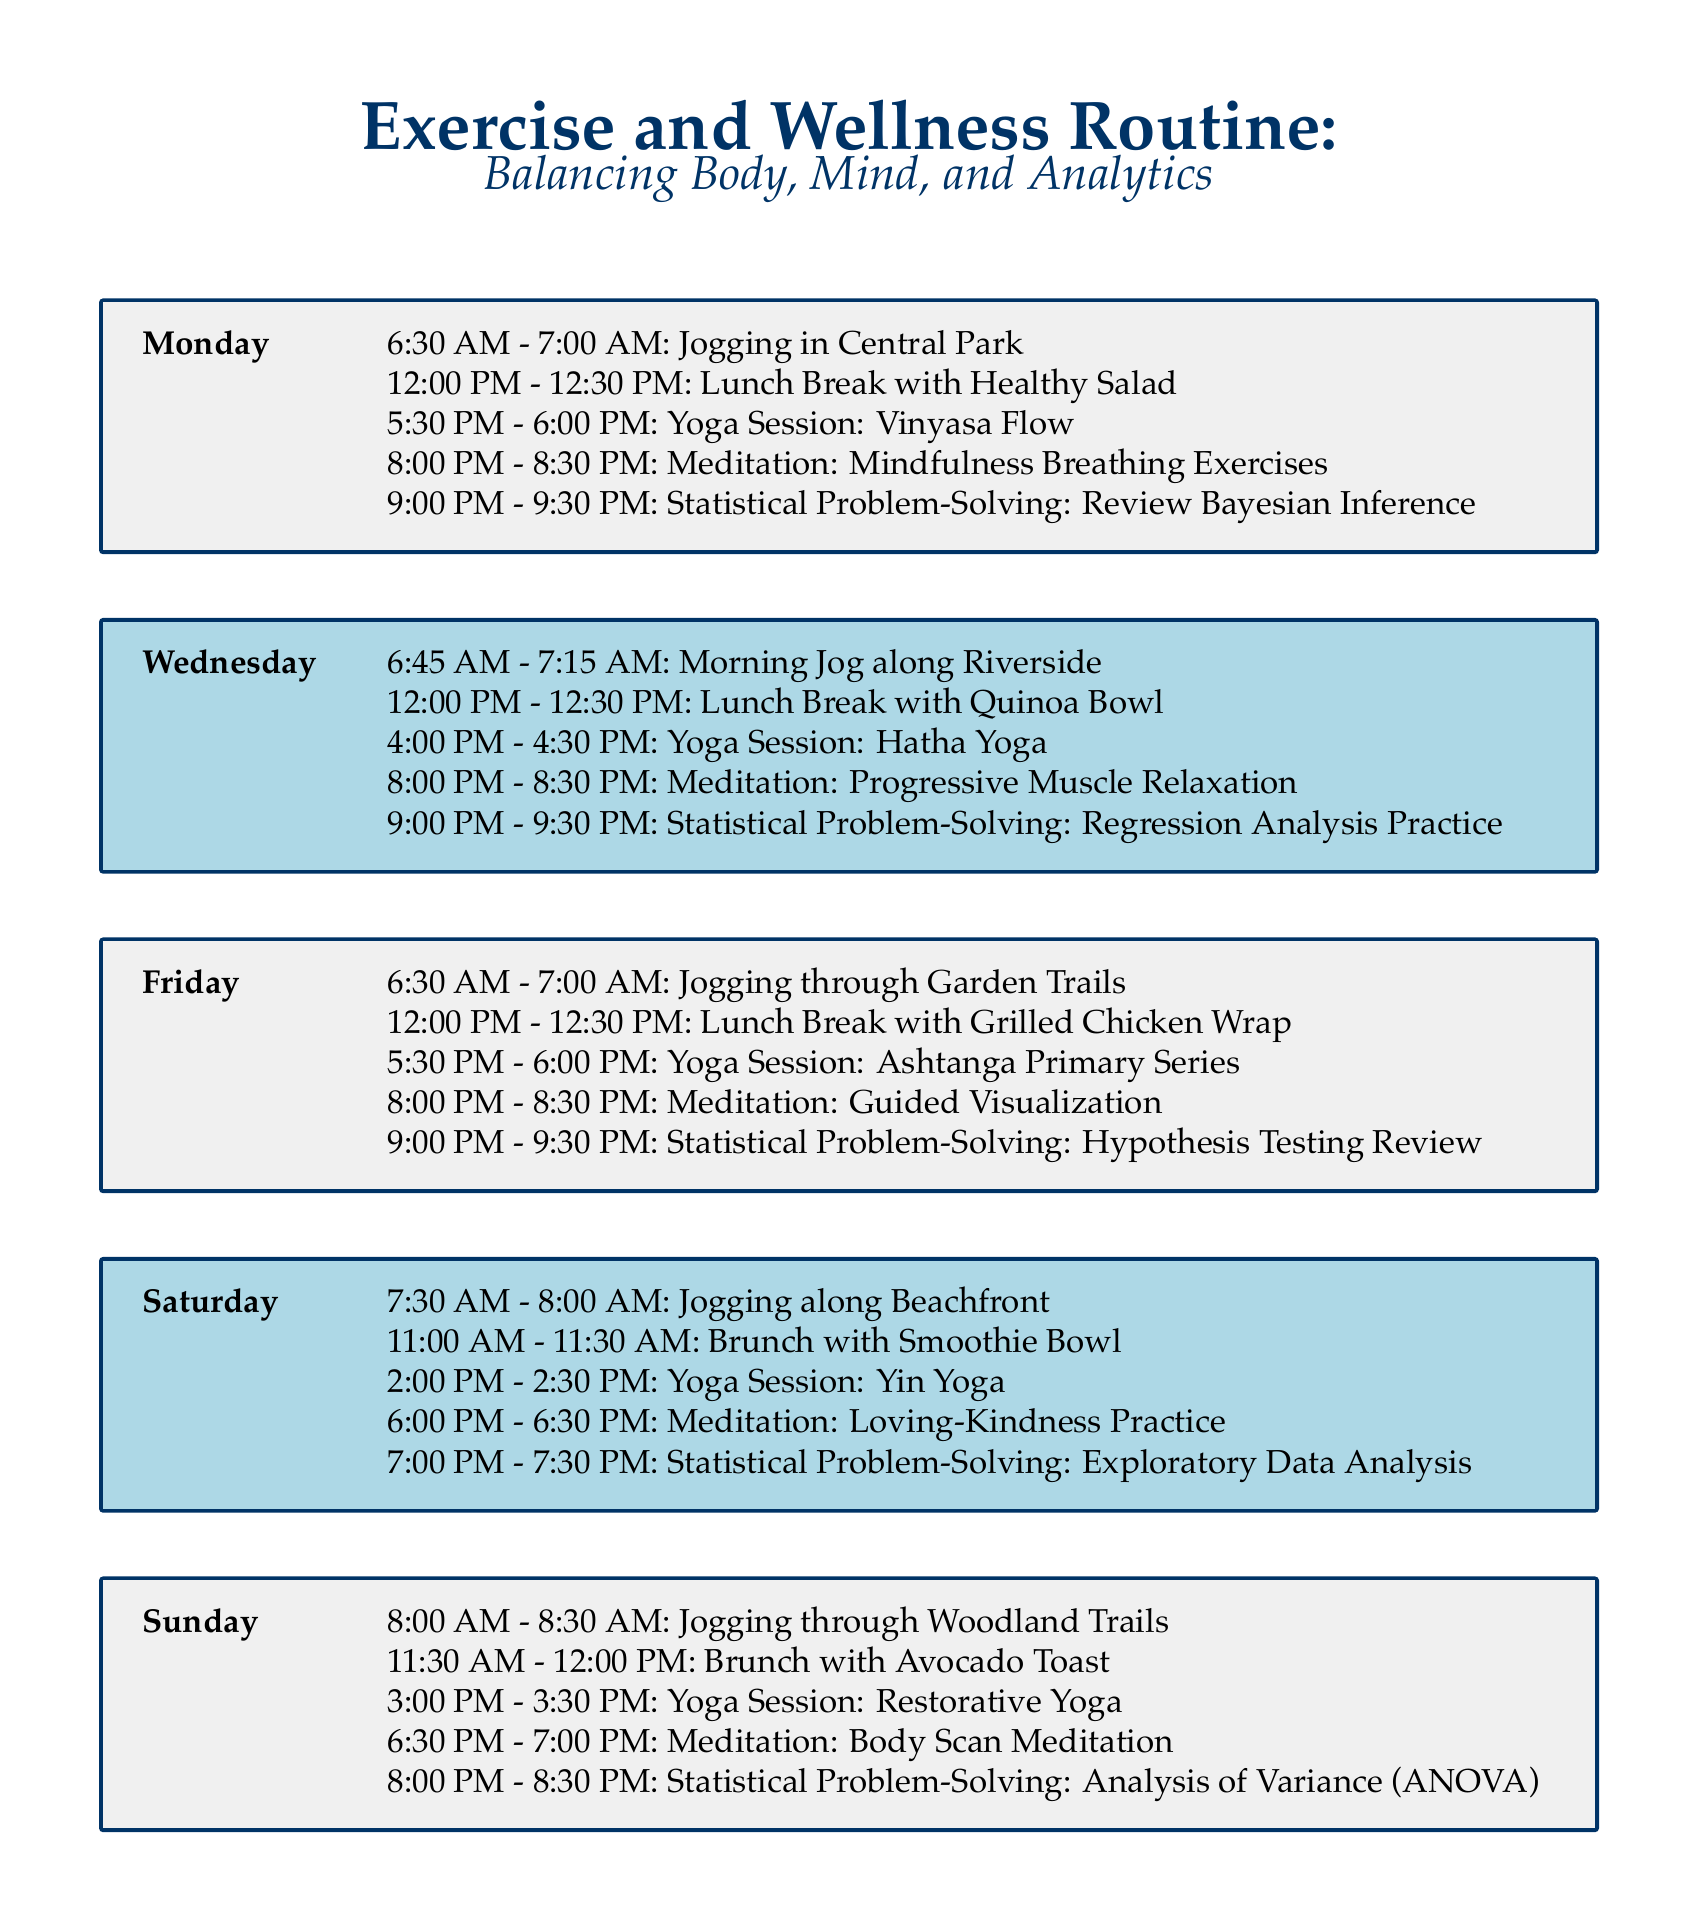What time is the yoga session on Monday? The Monday yoga session is scheduled for 5:30 PM - 6:00 PM.
Answer: 5:30 PM - 6:00 PM What type of yoga is practiced on Wednesday? The yoga session on Wednesday is Hatha Yoga.
Answer: Hatha Yoga How long is the meditation session on Saturday? The Saturday meditation session is 30 minutes long, from 6:00 PM to 6:30 PM.
Answer: 30 minutes What is the healthy lunch option on Friday? On Friday, the healthy lunch option is a Grilled Chicken Wrap.
Answer: Grilled Chicken Wrap How many statistical problem-solving sessions are scheduled in total? There are five statistical problem-solving sessions listed in the document, one for each day mentioned.
Answer: 5 Which day includes a Loving-Kindness meditation practice? The Loving-Kindness meditation practice is scheduled for Saturday.
Answer: Saturday What is allocated for lunchtime on Wednesday? On Wednesday, the lunch break consists of a Quinoa Bowl.
Answer: Quinoa Bowl What is the earliest jogging session in the schedule? The earliest jogging session is on Monday at 6:30 AM.
Answer: 6:30 AM 